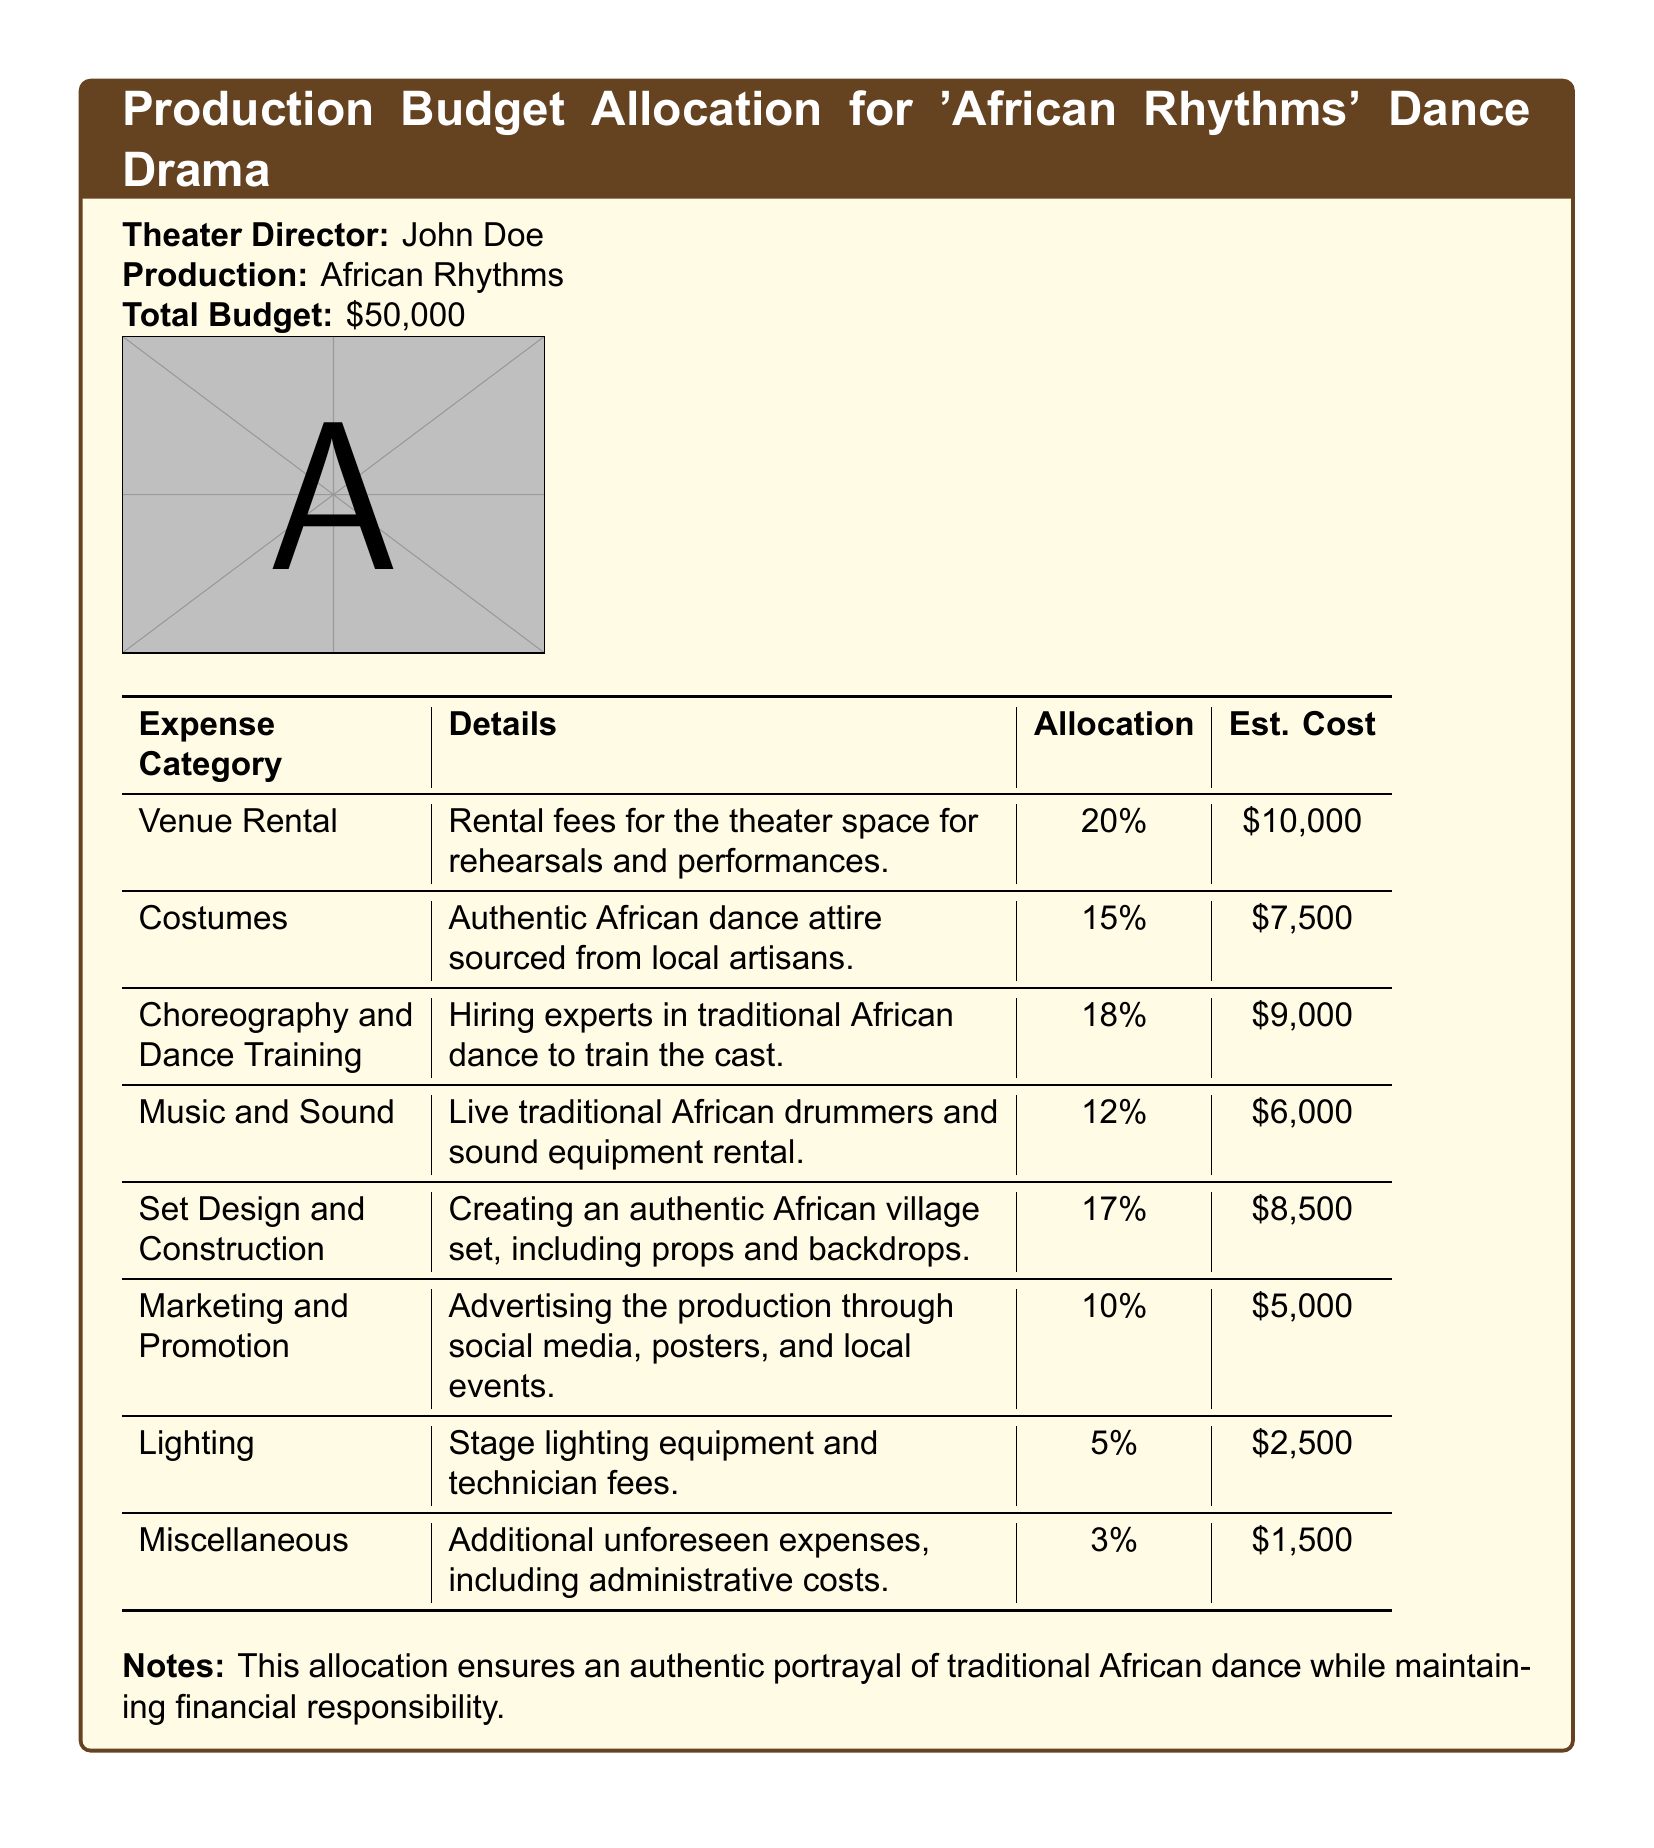What is the total budget for the production? The total budget is stated directly in the document.
Answer: $50,000 Who is the theater director for 'African Rhythms'? The name of the theater director is mentioned in the header portion of the document.
Answer: John Doe What percentage of the budget is allocated to venue rental? The percentage allocation for venue rental is specified in the expense category table.
Answer: 20% How much is allocated for costumes? The document outlines the allocation for costumes in the details section.
Answer: $7,500 What is the estimated cost for lighting? The estimated cost for lighting is directly mentioned under the expense category.
Answer: $2,500 Which expense category has the lowest allocation? This requires reasoning through the table to identify the smallest percentage allocation.
Answer: Miscellaneous How much is allocated for marketing and promotion? The allocation for marketing and promotion is noted in the expense category table.
Answer: $5,000 What is included in the miscellaneous category? The miscellaneous category describes additional unforeseen expenses.
Answer: Additional unforeseen expenses How many percent of the budget is allocated for music and sound? The music and sound allocation percentage is found in the details section of the expense table.
Answer: 12% 